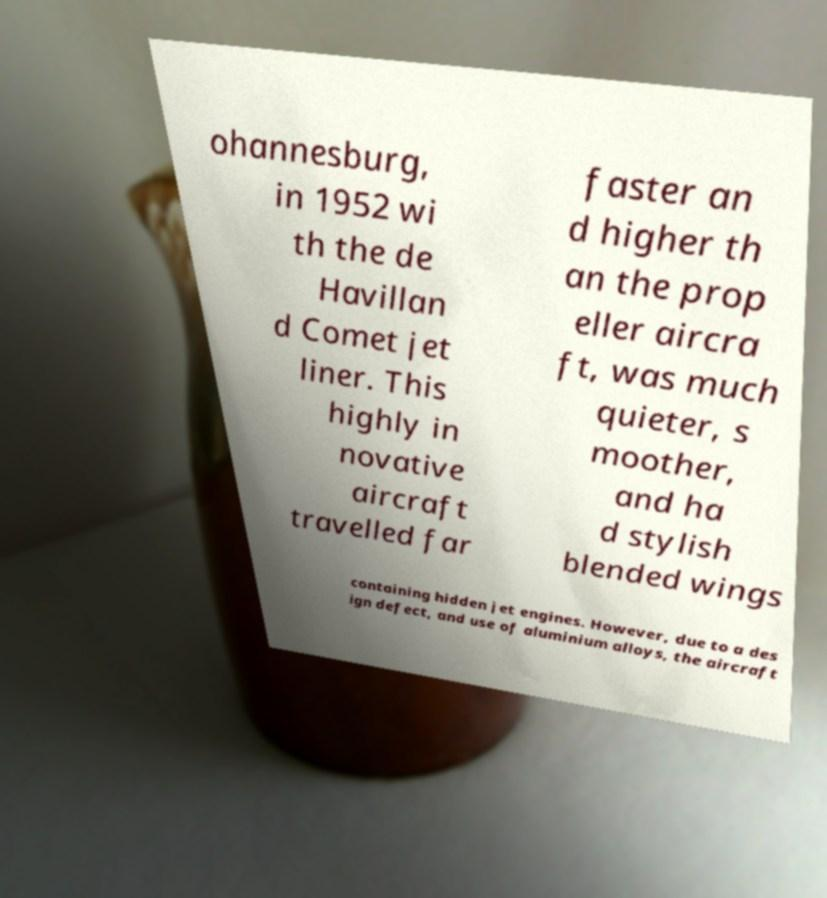For documentation purposes, I need the text within this image transcribed. Could you provide that? ohannesburg, in 1952 wi th the de Havillan d Comet jet liner. This highly in novative aircraft travelled far faster an d higher th an the prop eller aircra ft, was much quieter, s moother, and ha d stylish blended wings containing hidden jet engines. However, due to a des ign defect, and use of aluminium alloys, the aircraft 